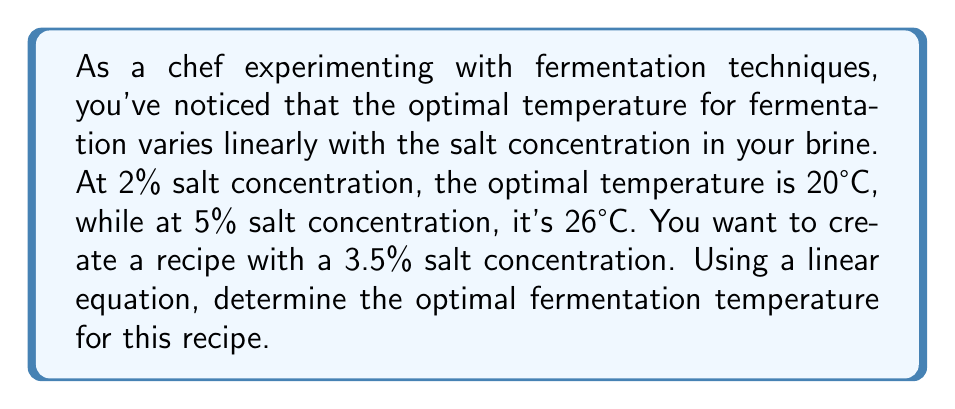Can you answer this question? Let's approach this step-by-step using a linear equation:

1) We can represent the relationship between salt concentration (x) and optimal temperature (y) as:

   $y = mx + b$

   Where m is the slope and b is the y-intercept.

2) We have two points: (2, 20) and (5, 26). Let's calculate the slope:

   $m = \frac{y_2 - y_1}{x_2 - x_1} = \frac{26 - 20}{5 - 2} = \frac{6}{3} = 2$

3) Now we can use either point to find b. Let's use (2, 20):

   $20 = 2(2) + b$
   $20 = 4 + b$
   $b = 16$

4) Our linear equation is:

   $y = 2x + 16$

5) To find the optimal temperature for 3.5% salt concentration, we substitute x = 3.5:

   $y = 2(3.5) + 16$
   $y = 7 + 16 = 23$

Therefore, the optimal fermentation temperature for a 3.5% salt concentration is 23°C.
Answer: 23°C 